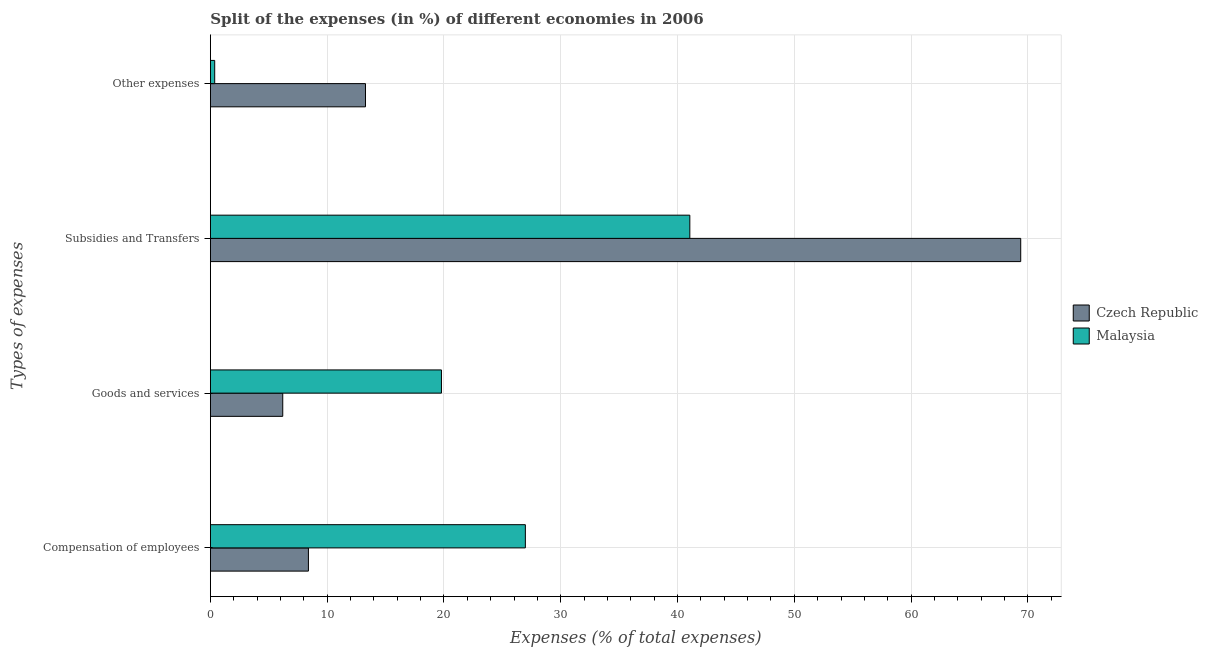Are the number of bars per tick equal to the number of legend labels?
Give a very brief answer. Yes. How many bars are there on the 3rd tick from the top?
Offer a very short reply. 2. What is the label of the 4th group of bars from the top?
Offer a terse response. Compensation of employees. What is the percentage of amount spent on goods and services in Czech Republic?
Ensure brevity in your answer.  6.2. Across all countries, what is the maximum percentage of amount spent on other expenses?
Keep it short and to the point. 13.28. Across all countries, what is the minimum percentage of amount spent on compensation of employees?
Offer a very short reply. 8.39. In which country was the percentage of amount spent on goods and services maximum?
Make the answer very short. Malaysia. In which country was the percentage of amount spent on other expenses minimum?
Make the answer very short. Malaysia. What is the total percentage of amount spent on subsidies in the graph?
Your answer should be very brief. 110.45. What is the difference between the percentage of amount spent on other expenses in Czech Republic and that in Malaysia?
Offer a terse response. 12.91. What is the difference between the percentage of amount spent on other expenses in Malaysia and the percentage of amount spent on subsidies in Czech Republic?
Provide a short and direct response. -69.02. What is the average percentage of amount spent on subsidies per country?
Offer a very short reply. 55.22. What is the difference between the percentage of amount spent on subsidies and percentage of amount spent on other expenses in Malaysia?
Provide a short and direct response. 40.69. In how many countries, is the percentage of amount spent on other expenses greater than 36 %?
Provide a short and direct response. 0. What is the ratio of the percentage of amount spent on compensation of employees in Malaysia to that in Czech Republic?
Offer a terse response. 3.21. Is the difference between the percentage of amount spent on other expenses in Czech Republic and Malaysia greater than the difference between the percentage of amount spent on subsidies in Czech Republic and Malaysia?
Your answer should be very brief. No. What is the difference between the highest and the second highest percentage of amount spent on other expenses?
Make the answer very short. 12.91. What is the difference between the highest and the lowest percentage of amount spent on other expenses?
Your answer should be compact. 12.91. Is the sum of the percentage of amount spent on other expenses in Malaysia and Czech Republic greater than the maximum percentage of amount spent on goods and services across all countries?
Provide a short and direct response. No. Is it the case that in every country, the sum of the percentage of amount spent on goods and services and percentage of amount spent on subsidies is greater than the sum of percentage of amount spent on compensation of employees and percentage of amount spent on other expenses?
Offer a terse response. No. What does the 1st bar from the top in Goods and services represents?
Offer a very short reply. Malaysia. What does the 1st bar from the bottom in Goods and services represents?
Provide a succinct answer. Czech Republic. Does the graph contain any zero values?
Offer a very short reply. No. Does the graph contain grids?
Your answer should be very brief. Yes. Where does the legend appear in the graph?
Offer a very short reply. Center right. How many legend labels are there?
Provide a short and direct response. 2. What is the title of the graph?
Offer a very short reply. Split of the expenses (in %) of different economies in 2006. What is the label or title of the X-axis?
Your response must be concise. Expenses (% of total expenses). What is the label or title of the Y-axis?
Provide a short and direct response. Types of expenses. What is the Expenses (% of total expenses) in Czech Republic in Compensation of employees?
Provide a succinct answer. 8.39. What is the Expenses (% of total expenses) of Malaysia in Compensation of employees?
Your response must be concise. 26.97. What is the Expenses (% of total expenses) of Czech Republic in Goods and services?
Give a very brief answer. 6.2. What is the Expenses (% of total expenses) in Malaysia in Goods and services?
Offer a terse response. 19.79. What is the Expenses (% of total expenses) of Czech Republic in Subsidies and Transfers?
Give a very brief answer. 69.39. What is the Expenses (% of total expenses) of Malaysia in Subsidies and Transfers?
Offer a terse response. 41.06. What is the Expenses (% of total expenses) in Czech Republic in Other expenses?
Your answer should be very brief. 13.28. What is the Expenses (% of total expenses) of Malaysia in Other expenses?
Keep it short and to the point. 0.37. Across all Types of expenses, what is the maximum Expenses (% of total expenses) of Czech Republic?
Give a very brief answer. 69.39. Across all Types of expenses, what is the maximum Expenses (% of total expenses) in Malaysia?
Ensure brevity in your answer.  41.06. Across all Types of expenses, what is the minimum Expenses (% of total expenses) of Czech Republic?
Keep it short and to the point. 6.2. Across all Types of expenses, what is the minimum Expenses (% of total expenses) in Malaysia?
Provide a succinct answer. 0.37. What is the total Expenses (% of total expenses) of Czech Republic in the graph?
Ensure brevity in your answer.  97.26. What is the total Expenses (% of total expenses) in Malaysia in the graph?
Offer a terse response. 88.18. What is the difference between the Expenses (% of total expenses) of Czech Republic in Compensation of employees and that in Goods and services?
Give a very brief answer. 2.2. What is the difference between the Expenses (% of total expenses) of Malaysia in Compensation of employees and that in Goods and services?
Make the answer very short. 7.19. What is the difference between the Expenses (% of total expenses) in Czech Republic in Compensation of employees and that in Subsidies and Transfers?
Provide a short and direct response. -61. What is the difference between the Expenses (% of total expenses) in Malaysia in Compensation of employees and that in Subsidies and Transfers?
Ensure brevity in your answer.  -14.08. What is the difference between the Expenses (% of total expenses) of Czech Republic in Compensation of employees and that in Other expenses?
Offer a very short reply. -4.89. What is the difference between the Expenses (% of total expenses) in Malaysia in Compensation of employees and that in Other expenses?
Keep it short and to the point. 26.6. What is the difference between the Expenses (% of total expenses) in Czech Republic in Goods and services and that in Subsidies and Transfers?
Give a very brief answer. -63.19. What is the difference between the Expenses (% of total expenses) in Malaysia in Goods and services and that in Subsidies and Transfers?
Your response must be concise. -21.27. What is the difference between the Expenses (% of total expenses) in Czech Republic in Goods and services and that in Other expenses?
Give a very brief answer. -7.08. What is the difference between the Expenses (% of total expenses) in Malaysia in Goods and services and that in Other expenses?
Your response must be concise. 19.42. What is the difference between the Expenses (% of total expenses) in Czech Republic in Subsidies and Transfers and that in Other expenses?
Your answer should be compact. 56.11. What is the difference between the Expenses (% of total expenses) of Malaysia in Subsidies and Transfers and that in Other expenses?
Ensure brevity in your answer.  40.69. What is the difference between the Expenses (% of total expenses) in Czech Republic in Compensation of employees and the Expenses (% of total expenses) in Malaysia in Goods and services?
Make the answer very short. -11.39. What is the difference between the Expenses (% of total expenses) of Czech Republic in Compensation of employees and the Expenses (% of total expenses) of Malaysia in Subsidies and Transfers?
Provide a short and direct response. -32.66. What is the difference between the Expenses (% of total expenses) of Czech Republic in Compensation of employees and the Expenses (% of total expenses) of Malaysia in Other expenses?
Your answer should be very brief. 8.02. What is the difference between the Expenses (% of total expenses) in Czech Republic in Goods and services and the Expenses (% of total expenses) in Malaysia in Subsidies and Transfers?
Make the answer very short. -34.86. What is the difference between the Expenses (% of total expenses) in Czech Republic in Goods and services and the Expenses (% of total expenses) in Malaysia in Other expenses?
Provide a short and direct response. 5.83. What is the difference between the Expenses (% of total expenses) in Czech Republic in Subsidies and Transfers and the Expenses (% of total expenses) in Malaysia in Other expenses?
Make the answer very short. 69.02. What is the average Expenses (% of total expenses) in Czech Republic per Types of expenses?
Ensure brevity in your answer.  24.32. What is the average Expenses (% of total expenses) in Malaysia per Types of expenses?
Offer a terse response. 22.05. What is the difference between the Expenses (% of total expenses) in Czech Republic and Expenses (% of total expenses) in Malaysia in Compensation of employees?
Ensure brevity in your answer.  -18.58. What is the difference between the Expenses (% of total expenses) in Czech Republic and Expenses (% of total expenses) in Malaysia in Goods and services?
Ensure brevity in your answer.  -13.59. What is the difference between the Expenses (% of total expenses) of Czech Republic and Expenses (% of total expenses) of Malaysia in Subsidies and Transfers?
Your answer should be very brief. 28.33. What is the difference between the Expenses (% of total expenses) in Czech Republic and Expenses (% of total expenses) in Malaysia in Other expenses?
Ensure brevity in your answer.  12.91. What is the ratio of the Expenses (% of total expenses) in Czech Republic in Compensation of employees to that in Goods and services?
Your answer should be compact. 1.35. What is the ratio of the Expenses (% of total expenses) in Malaysia in Compensation of employees to that in Goods and services?
Provide a succinct answer. 1.36. What is the ratio of the Expenses (% of total expenses) in Czech Republic in Compensation of employees to that in Subsidies and Transfers?
Provide a short and direct response. 0.12. What is the ratio of the Expenses (% of total expenses) of Malaysia in Compensation of employees to that in Subsidies and Transfers?
Offer a very short reply. 0.66. What is the ratio of the Expenses (% of total expenses) of Czech Republic in Compensation of employees to that in Other expenses?
Your answer should be compact. 0.63. What is the ratio of the Expenses (% of total expenses) of Malaysia in Compensation of employees to that in Other expenses?
Offer a very short reply. 72.98. What is the ratio of the Expenses (% of total expenses) in Czech Republic in Goods and services to that in Subsidies and Transfers?
Keep it short and to the point. 0.09. What is the ratio of the Expenses (% of total expenses) in Malaysia in Goods and services to that in Subsidies and Transfers?
Give a very brief answer. 0.48. What is the ratio of the Expenses (% of total expenses) of Czech Republic in Goods and services to that in Other expenses?
Keep it short and to the point. 0.47. What is the ratio of the Expenses (% of total expenses) of Malaysia in Goods and services to that in Other expenses?
Offer a terse response. 53.54. What is the ratio of the Expenses (% of total expenses) in Czech Republic in Subsidies and Transfers to that in Other expenses?
Your answer should be compact. 5.22. What is the ratio of the Expenses (% of total expenses) of Malaysia in Subsidies and Transfers to that in Other expenses?
Your answer should be very brief. 111.09. What is the difference between the highest and the second highest Expenses (% of total expenses) of Czech Republic?
Your answer should be very brief. 56.11. What is the difference between the highest and the second highest Expenses (% of total expenses) in Malaysia?
Provide a succinct answer. 14.08. What is the difference between the highest and the lowest Expenses (% of total expenses) of Czech Republic?
Give a very brief answer. 63.19. What is the difference between the highest and the lowest Expenses (% of total expenses) of Malaysia?
Your answer should be compact. 40.69. 